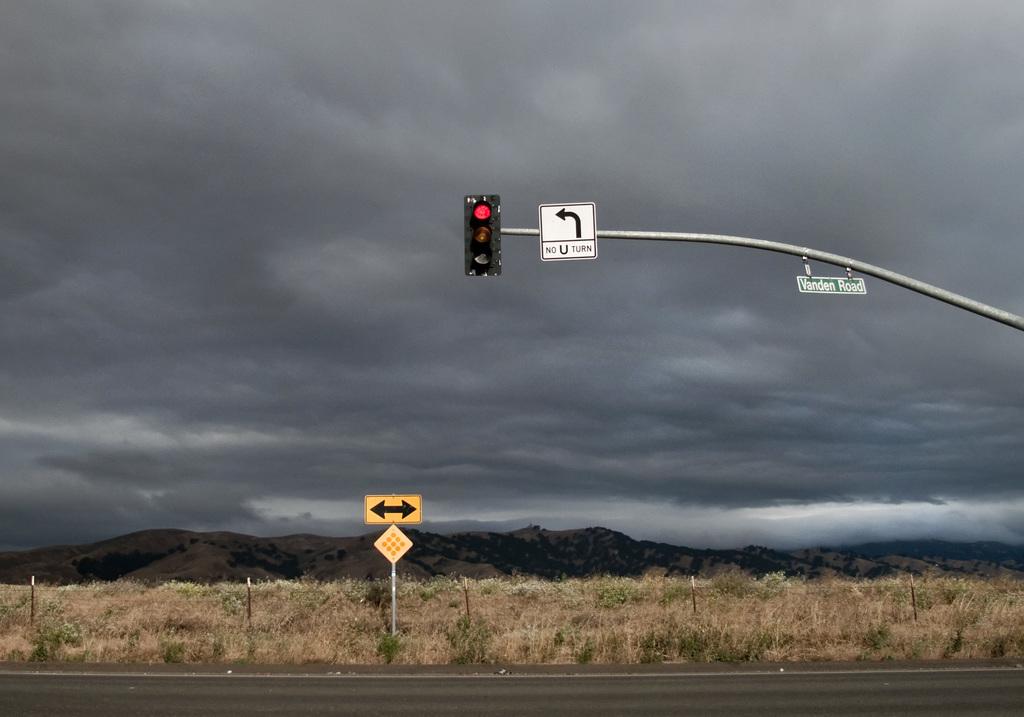What kind of turn is not permitted here?
Give a very brief answer. U. What does the sign say is not permitted?
Your answer should be very brief. No u turn. 